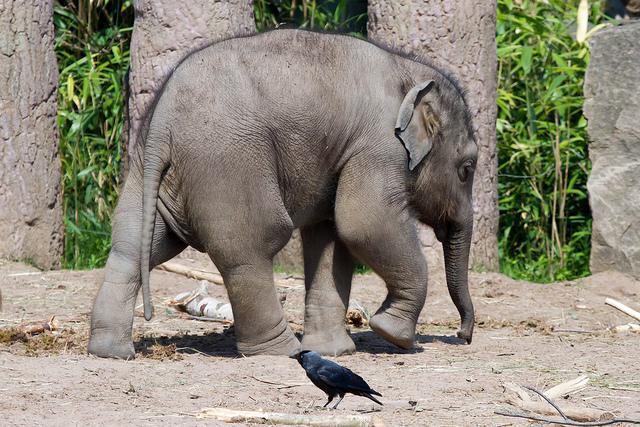Evaluate: Does the caption "The bird is facing the elephant." match the image?
Answer yes or no. No. 